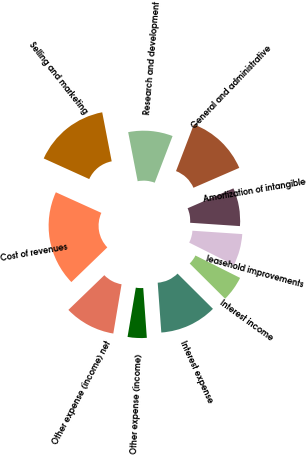Convert chart. <chart><loc_0><loc_0><loc_500><loc_500><pie_chart><fcel>Cost of revenues<fcel>Selling and marketing<fcel>Research and development<fcel>General and administrative<fcel>Amortization of intangible<fcel>leasehold improvements<fcel>Interest income<fcel>Interest expense<fcel>Other expense (income)<fcel>Other expense (income) net<nl><fcel>18.99%<fcel>15.19%<fcel>8.86%<fcel>12.66%<fcel>7.59%<fcel>6.33%<fcel>5.06%<fcel>11.39%<fcel>3.8%<fcel>10.13%<nl></chart> 